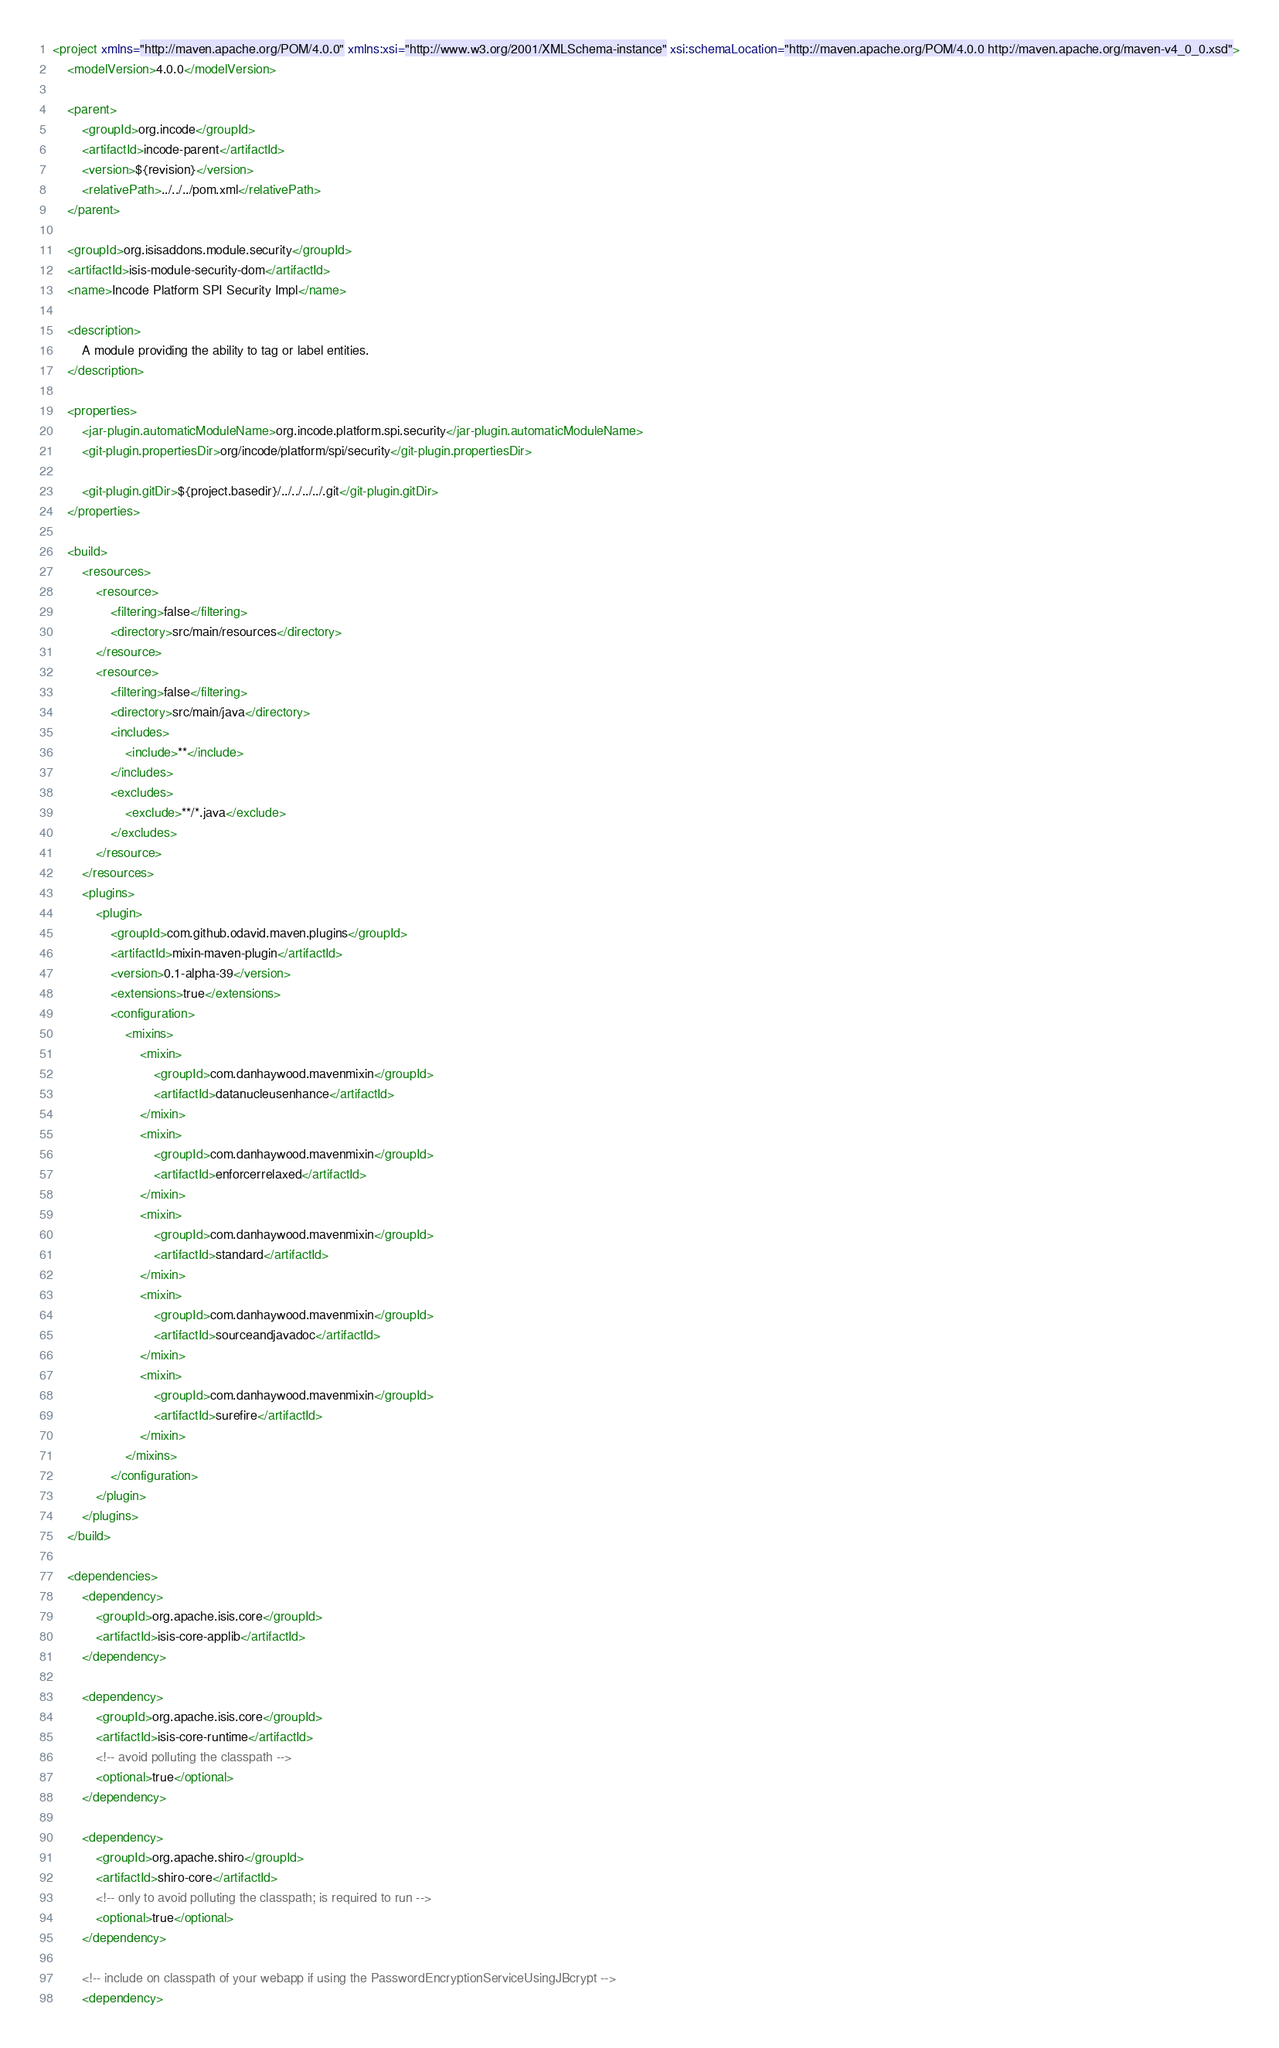Convert code to text. <code><loc_0><loc_0><loc_500><loc_500><_XML_><project xmlns="http://maven.apache.org/POM/4.0.0" xmlns:xsi="http://www.w3.org/2001/XMLSchema-instance" xsi:schemaLocation="http://maven.apache.org/POM/4.0.0 http://maven.apache.org/maven-v4_0_0.xsd">
    <modelVersion>4.0.0</modelVersion>

    <parent>
        <groupId>org.incode</groupId>
        <artifactId>incode-parent</artifactId>
        <version>${revision}</version>
        <relativePath>../../../pom.xml</relativePath>
    </parent>

    <groupId>org.isisaddons.module.security</groupId>
    <artifactId>isis-module-security-dom</artifactId>
    <name>Incode Platform SPI Security Impl</name>

    <description>
        A module providing the ability to tag or label entities.
    </description>

    <properties>
        <jar-plugin.automaticModuleName>org.incode.platform.spi.security</jar-plugin.automaticModuleName>
        <git-plugin.propertiesDir>org/incode/platform/spi/security</git-plugin.propertiesDir>

        <git-plugin.gitDir>${project.basedir}/../../../../.git</git-plugin.gitDir>
    </properties>

    <build>
        <resources>
            <resource>
                <filtering>false</filtering>
                <directory>src/main/resources</directory>
            </resource>
            <resource>
                <filtering>false</filtering>
                <directory>src/main/java</directory>
                <includes>
                    <include>**</include>
                </includes>
                <excludes>
                    <exclude>**/*.java</exclude>
                </excludes>
            </resource>
        </resources>
        <plugins>
            <plugin>
                <groupId>com.github.odavid.maven.plugins</groupId>
                <artifactId>mixin-maven-plugin</artifactId>
                <version>0.1-alpha-39</version>
                <extensions>true</extensions>
                <configuration>
                    <mixins>
                        <mixin>
                            <groupId>com.danhaywood.mavenmixin</groupId>
                            <artifactId>datanucleusenhance</artifactId>
                        </mixin>
                        <mixin>
                            <groupId>com.danhaywood.mavenmixin</groupId>
                            <artifactId>enforcerrelaxed</artifactId>
                        </mixin>
                        <mixin>
                            <groupId>com.danhaywood.mavenmixin</groupId>
                            <artifactId>standard</artifactId>
                        </mixin>
                        <mixin>
                            <groupId>com.danhaywood.mavenmixin</groupId>
                            <artifactId>sourceandjavadoc</artifactId>
                        </mixin>
                        <mixin>
                            <groupId>com.danhaywood.mavenmixin</groupId>
                            <artifactId>surefire</artifactId>
                        </mixin>
                    </mixins>
                </configuration>
            </plugin>
        </plugins>
    </build>

    <dependencies>
        <dependency>
            <groupId>org.apache.isis.core</groupId>
            <artifactId>isis-core-applib</artifactId>
        </dependency>

        <dependency>
            <groupId>org.apache.isis.core</groupId>
            <artifactId>isis-core-runtime</artifactId>
            <!-- avoid polluting the classpath -->
            <optional>true</optional>
        </dependency>

        <dependency>
            <groupId>org.apache.shiro</groupId>
            <artifactId>shiro-core</artifactId>
            <!-- only to avoid polluting the classpath; is required to run -->
            <optional>true</optional>
        </dependency>

        <!-- include on classpath of your webapp if using the PasswordEncryptionServiceUsingJBcrypt -->
        <dependency></code> 